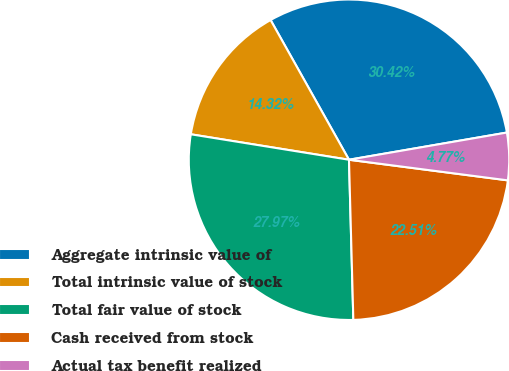Convert chart to OTSL. <chart><loc_0><loc_0><loc_500><loc_500><pie_chart><fcel>Aggregate intrinsic value of<fcel>Total intrinsic value of stock<fcel>Total fair value of stock<fcel>Cash received from stock<fcel>Actual tax benefit realized<nl><fcel>30.42%<fcel>14.32%<fcel>27.97%<fcel>22.51%<fcel>4.77%<nl></chart> 